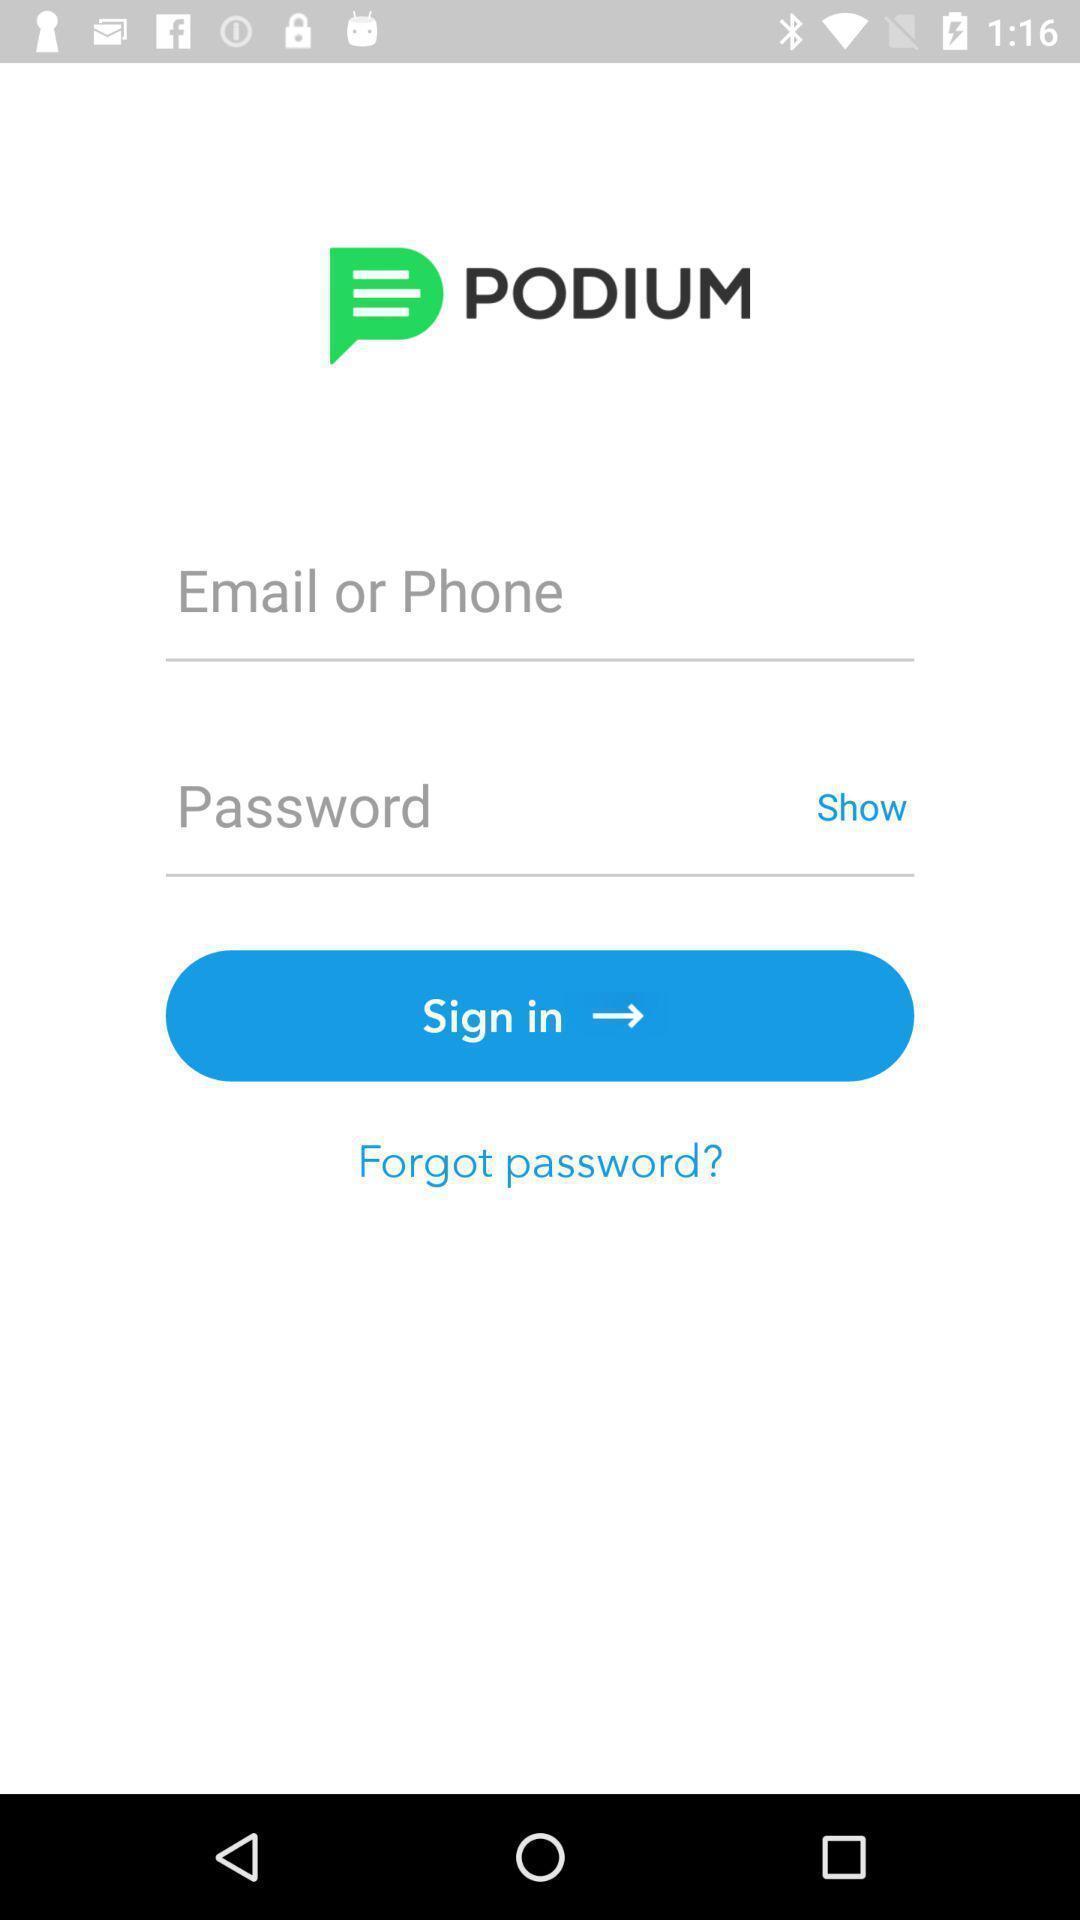What details can you identify in this image? Sign in page. 